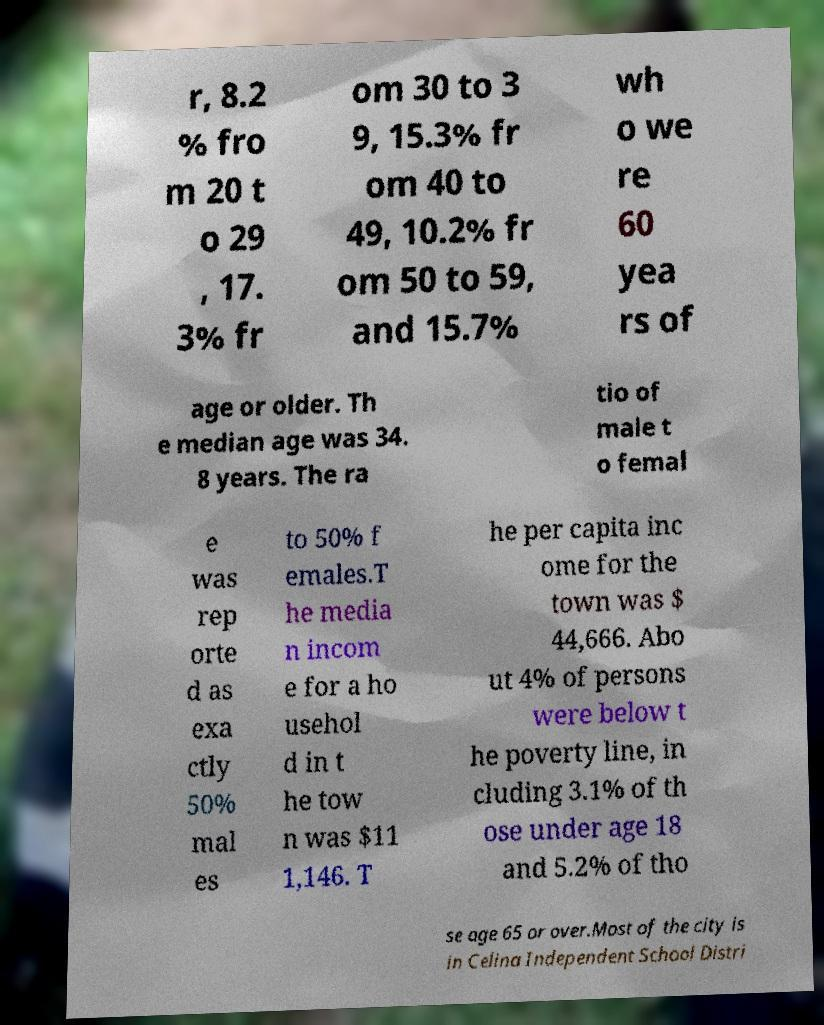For documentation purposes, I need the text within this image transcribed. Could you provide that? r, 8.2 % fro m 20 t o 29 , 17. 3% fr om 30 to 3 9, 15.3% fr om 40 to 49, 10.2% fr om 50 to 59, and 15.7% wh o we re 60 yea rs of age or older. Th e median age was 34. 8 years. The ra tio of male t o femal e was rep orte d as exa ctly 50% mal es to 50% f emales.T he media n incom e for a ho usehol d in t he tow n was $11 1,146. T he per capita inc ome for the town was $ 44,666. Abo ut 4% of persons were below t he poverty line, in cluding 3.1% of th ose under age 18 and 5.2% of tho se age 65 or over.Most of the city is in Celina Independent School Distri 